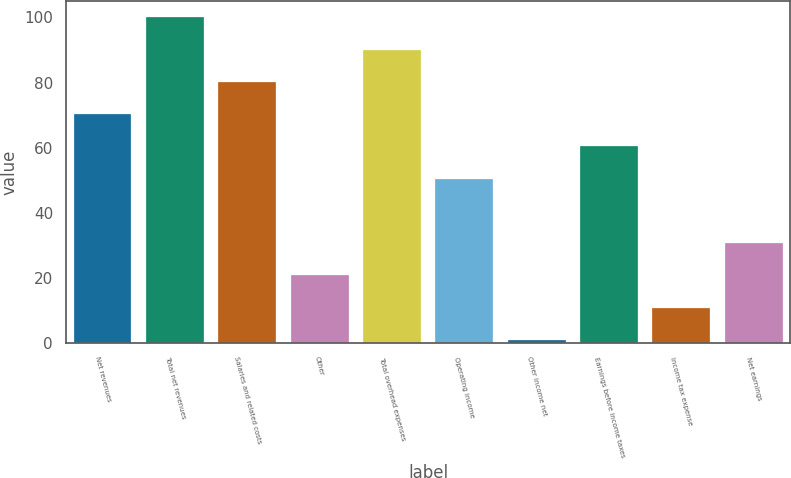Convert chart to OTSL. <chart><loc_0><loc_0><loc_500><loc_500><bar_chart><fcel>Net revenues<fcel>Total net revenues<fcel>Salaries and related costs<fcel>Other<fcel>Total overhead expenses<fcel>Operating income<fcel>Other income net<fcel>Earnings before income taxes<fcel>Income tax expense<fcel>Net earnings<nl><fcel>70.3<fcel>100<fcel>80.2<fcel>20.8<fcel>90.1<fcel>50.5<fcel>1<fcel>60.4<fcel>10.9<fcel>30.7<nl></chart> 